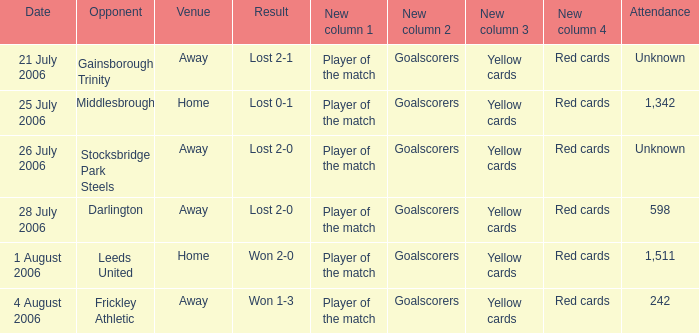What is the result from the Leeds United opponent? Won 2-0. 